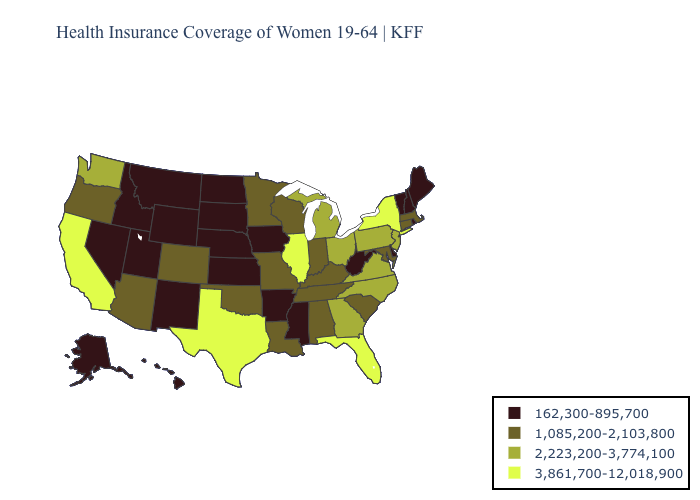What is the value of Iowa?
Keep it brief. 162,300-895,700. Name the states that have a value in the range 162,300-895,700?
Answer briefly. Alaska, Arkansas, Delaware, Hawaii, Idaho, Iowa, Kansas, Maine, Mississippi, Montana, Nebraska, Nevada, New Hampshire, New Mexico, North Dakota, Rhode Island, South Dakota, Utah, Vermont, West Virginia, Wyoming. Name the states that have a value in the range 2,223,200-3,774,100?
Give a very brief answer. Georgia, Michigan, New Jersey, North Carolina, Ohio, Pennsylvania, Virginia, Washington. Name the states that have a value in the range 2,223,200-3,774,100?
Answer briefly. Georgia, Michigan, New Jersey, North Carolina, Ohio, Pennsylvania, Virginia, Washington. How many symbols are there in the legend?
Short answer required. 4. Which states have the lowest value in the Northeast?
Give a very brief answer. Maine, New Hampshire, Rhode Island, Vermont. Name the states that have a value in the range 1,085,200-2,103,800?
Short answer required. Alabama, Arizona, Colorado, Connecticut, Indiana, Kentucky, Louisiana, Maryland, Massachusetts, Minnesota, Missouri, Oklahoma, Oregon, South Carolina, Tennessee, Wisconsin. What is the value of Kentucky?
Give a very brief answer. 1,085,200-2,103,800. What is the highest value in the USA?
Quick response, please. 3,861,700-12,018,900. Name the states that have a value in the range 2,223,200-3,774,100?
Concise answer only. Georgia, Michigan, New Jersey, North Carolina, Ohio, Pennsylvania, Virginia, Washington. What is the lowest value in the USA?
Quick response, please. 162,300-895,700. Among the states that border Missouri , which have the highest value?
Concise answer only. Illinois. Does New York have the highest value in the USA?
Give a very brief answer. Yes. Which states have the lowest value in the MidWest?
Give a very brief answer. Iowa, Kansas, Nebraska, North Dakota, South Dakota. Does Oklahoma have the same value as Indiana?
Keep it brief. Yes. 